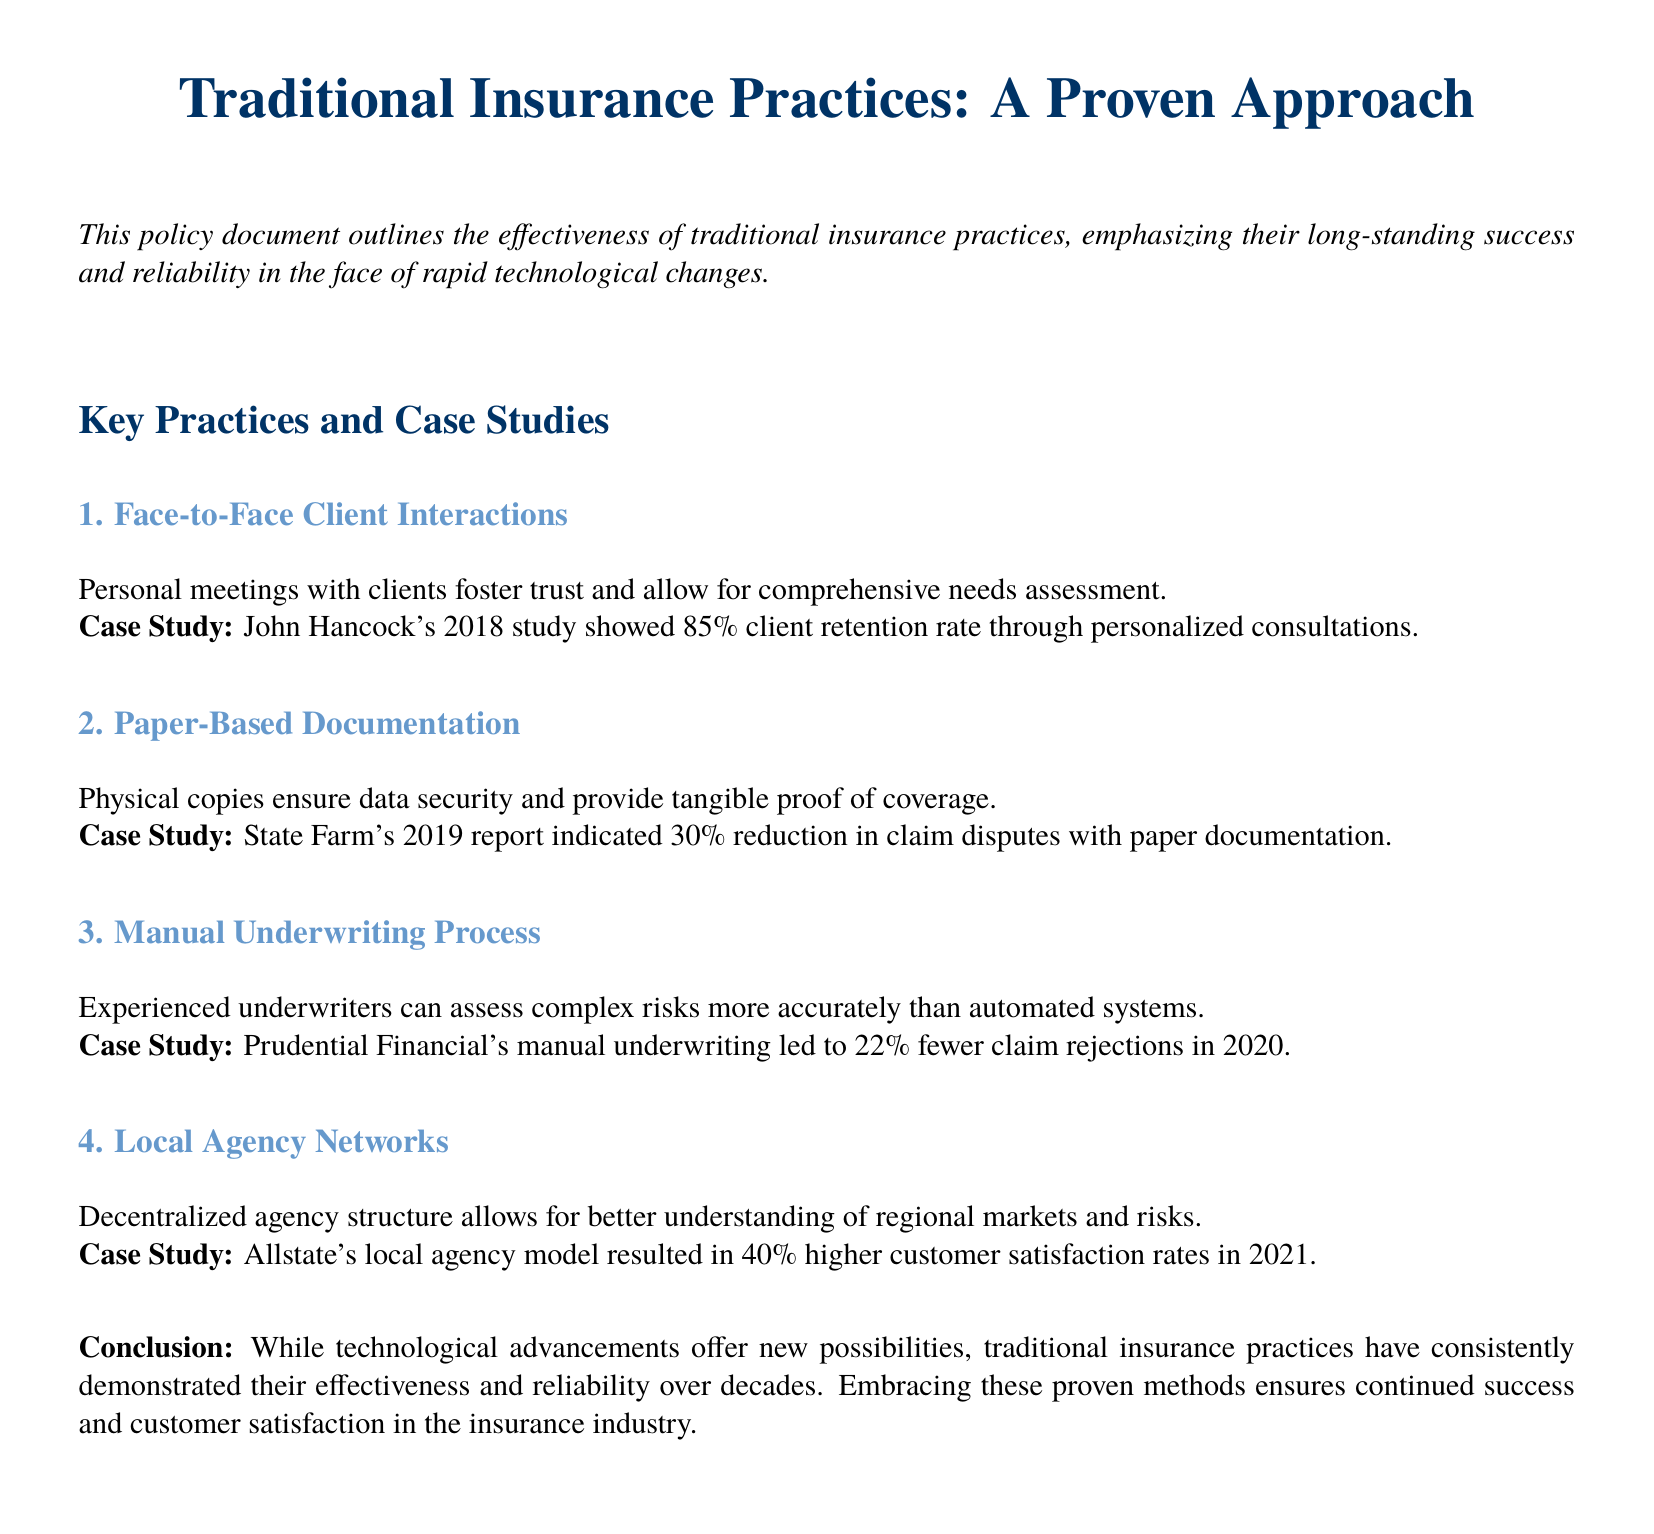What is the title of the document? The title is provided in the header section of the document.
Answer: Traditional Insurance Practices: A Proven Approach What percentage of client retention was achieved through personalized consultations? The document mentions a specific retention rate from a case study.
Answer: 85% What documentation method resulted in a reduction of claim disputes? The document identifies a specific method associated with the reduction in claim disputes.
Answer: Paper-Based Documentation Which company reported a 22% decrease in claim rejections through manual underwriting? The document provides a case study example of a specific company related to this statistic.
Answer: Prudential Financial What was the customer satisfaction rate increase for Allstate's local agency model? The document states a percentage related to customer satisfaction from a case study.
Answer: 40% What is emphasized as a benefit of face-to-face client interactions? The document describes an outcome of this practice.
Answer: Trust In what year did John Hancock conduct its study? The document references the year associated with the case study.
Answer: 2018 What is the main conclusion drawn in the document? The conclusion reflects the overall message of the document regarding traditional practices.
Answer: Effectiveness and reliability What method allows for a better understanding of regional markets? The document lists practices, highlighting their advantages.
Answer: Local Agency Networks 